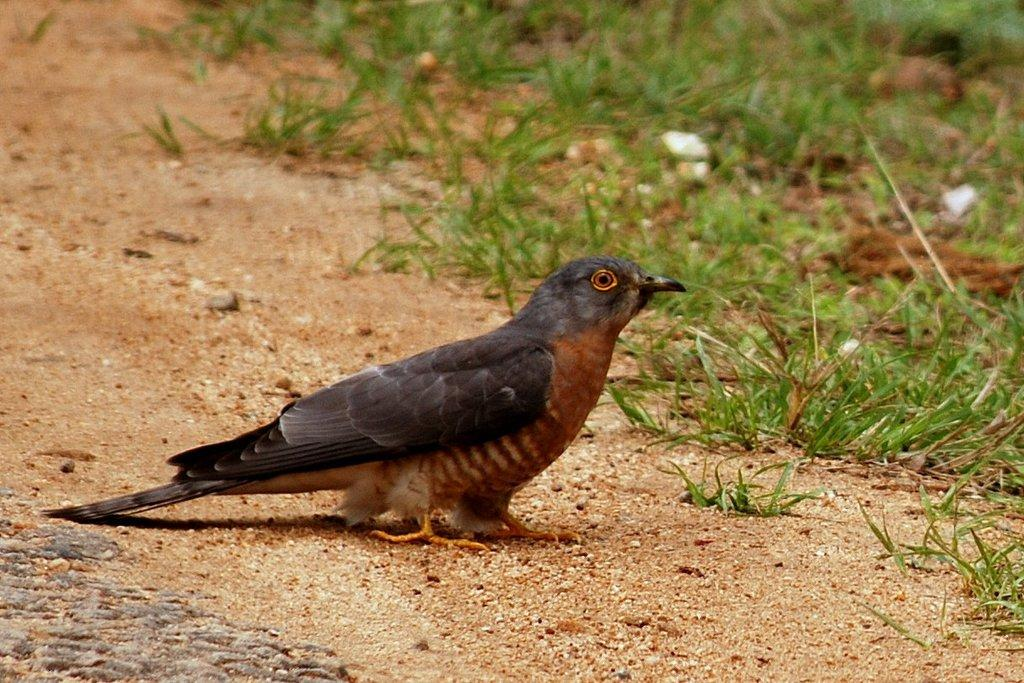What animal can be seen on the ground in the image? There is a bird on the ground in the image. What type of vegetation is present on the right side of the image? There is small grass on the right side of the image. What type of material is present on the sand in the image? There are stones on the sand in the image. What type of fish can be seen swimming in the water in the image? There is no water or fish present in the image; it features a bird on the ground and stones on the sand. 